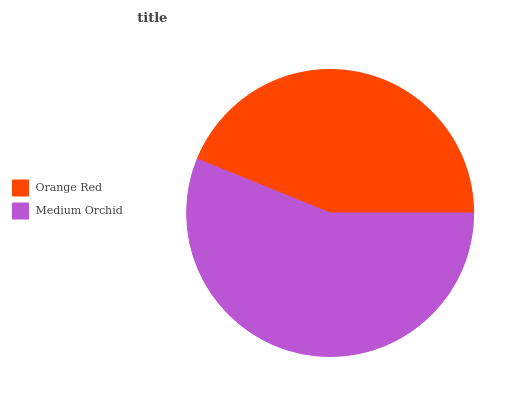Is Orange Red the minimum?
Answer yes or no. Yes. Is Medium Orchid the maximum?
Answer yes or no. Yes. Is Medium Orchid the minimum?
Answer yes or no. No. Is Medium Orchid greater than Orange Red?
Answer yes or no. Yes. Is Orange Red less than Medium Orchid?
Answer yes or no. Yes. Is Orange Red greater than Medium Orchid?
Answer yes or no. No. Is Medium Orchid less than Orange Red?
Answer yes or no. No. Is Medium Orchid the high median?
Answer yes or no. Yes. Is Orange Red the low median?
Answer yes or no. Yes. Is Orange Red the high median?
Answer yes or no. No. Is Medium Orchid the low median?
Answer yes or no. No. 